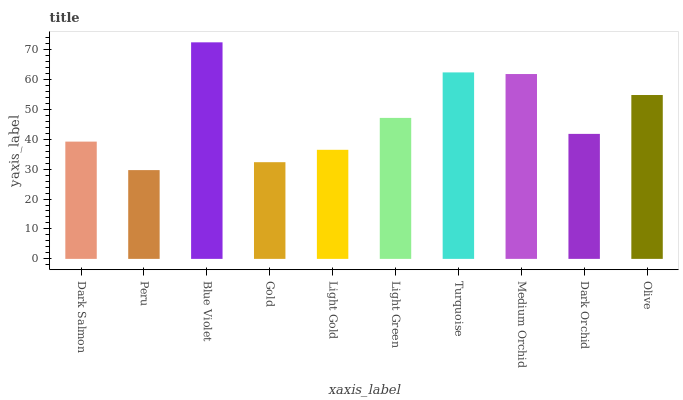Is Peru the minimum?
Answer yes or no. Yes. Is Blue Violet the maximum?
Answer yes or no. Yes. Is Blue Violet the minimum?
Answer yes or no. No. Is Peru the maximum?
Answer yes or no. No. Is Blue Violet greater than Peru?
Answer yes or no. Yes. Is Peru less than Blue Violet?
Answer yes or no. Yes. Is Peru greater than Blue Violet?
Answer yes or no. No. Is Blue Violet less than Peru?
Answer yes or no. No. Is Light Green the high median?
Answer yes or no. Yes. Is Dark Orchid the low median?
Answer yes or no. Yes. Is Peru the high median?
Answer yes or no. No. Is Light Green the low median?
Answer yes or no. No. 